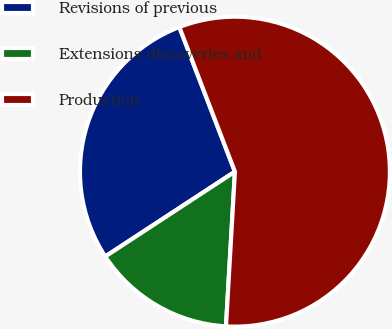Convert chart. <chart><loc_0><loc_0><loc_500><loc_500><pie_chart><fcel>Revisions of previous<fcel>Extensions discoveries and<fcel>Production<nl><fcel>28.38%<fcel>14.86%<fcel>56.76%<nl></chart> 